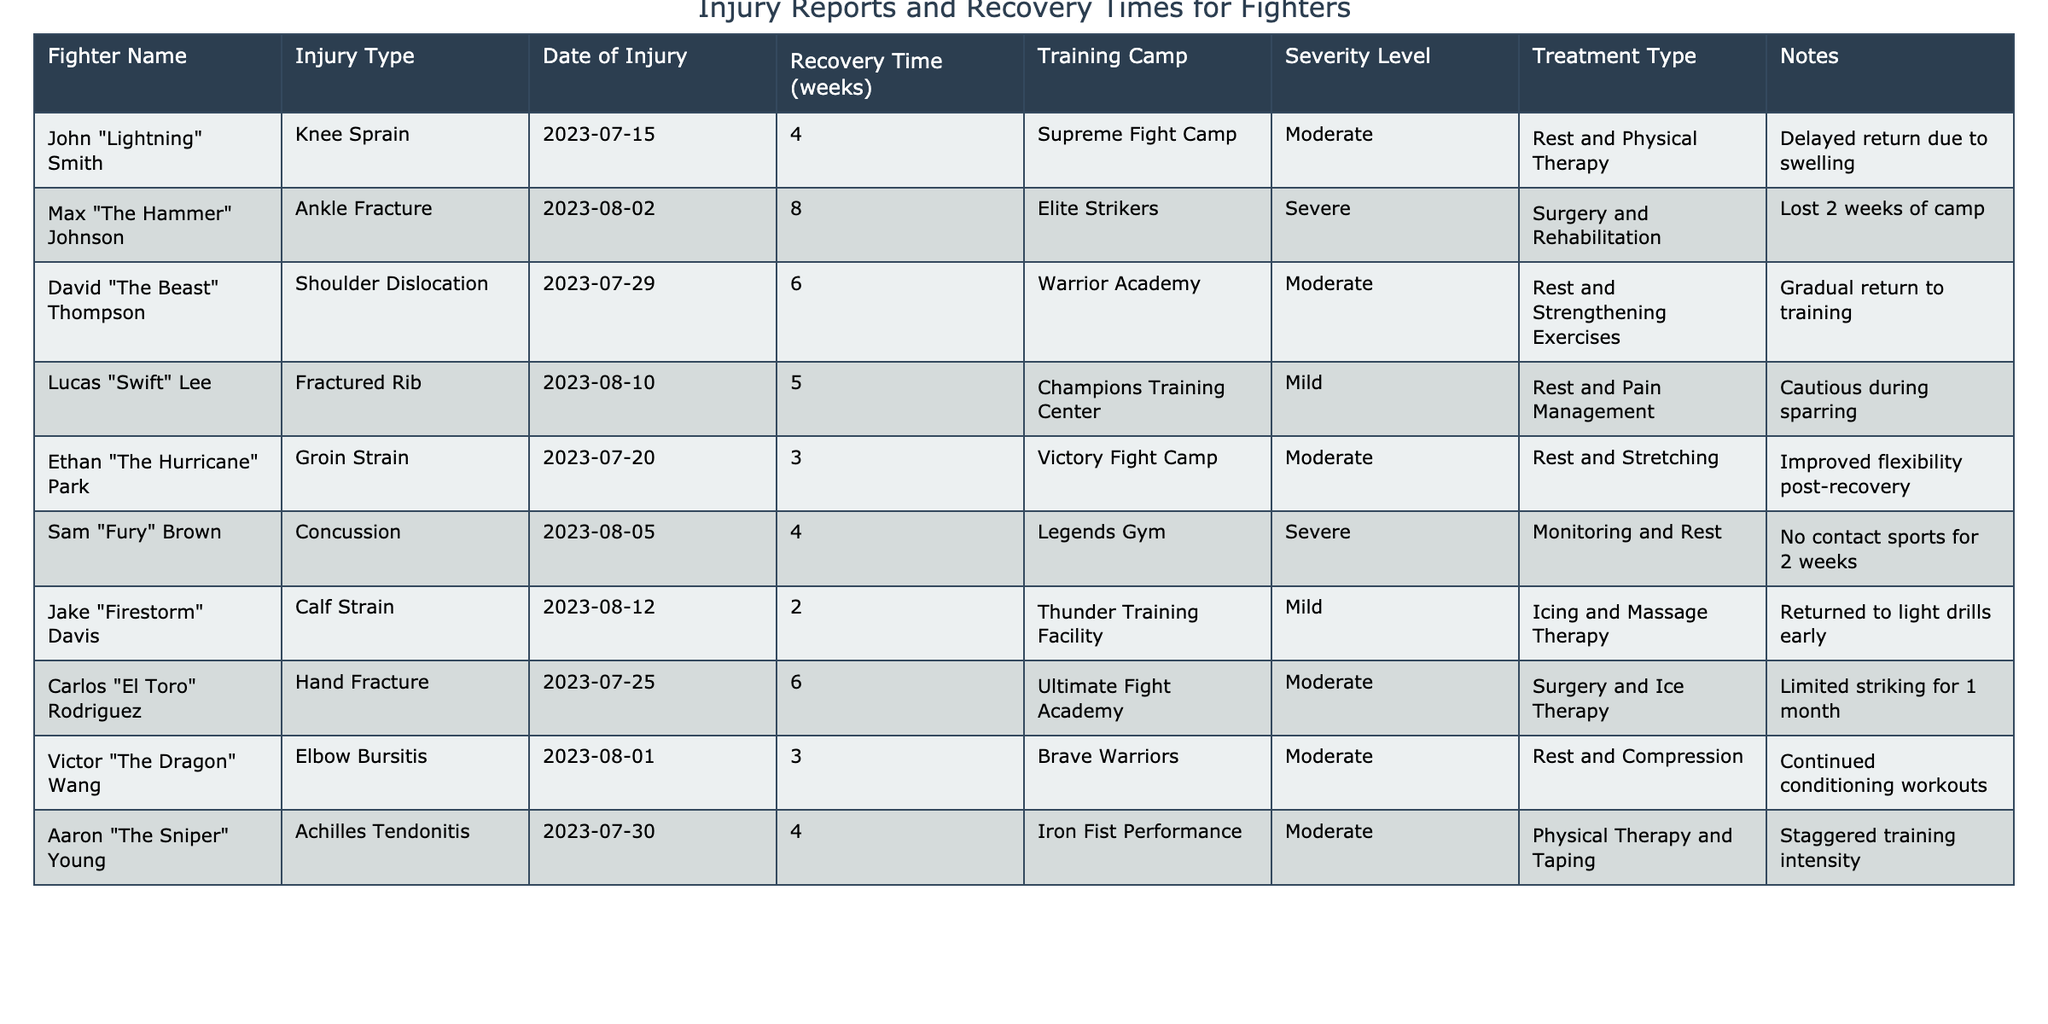What is the injury type for Max "The Hammer" Johnson? From the table, I can find that the injury type listed for Max "The Hammer" Johnson is Ankle Fracture.
Answer: Ankle Fracture How long did John "Lightning" Smith take to recover from his injury? The recovery time for John "Lightning" Smith is stated in the table as 4 weeks.
Answer: 4 weeks Which fighter had a recovery time of 3 weeks? By checking the table, I see that Ethan "The Hurricane" Park has a recovery time of 3 weeks due to a Groin Strain.
Answer: Ethan "The Hurricane" Park What is the average recovery time for the fighters listed? The recovery times are 4, 8, 6, 5, 3, 4, 2, 6, 3, and 4 weeks respectively. Adding these gives a total of 45 weeks, and with 10 fighters, the average is 45/10 = 4.5 weeks.
Answer: 4.5 weeks Is there any fighter with a severe injury severity level? Yes, there are two fighters listed with a severity level of Severe: Max "The Hammer" Johnson and Sam "Fury" Brown.
Answer: Yes Which fighter had the longest recovery time and what was it? Looking through the table, Max "The Hammer" Johnson had the longest recovery time of 8 weeks due to an Ankle Fracture.
Answer: Max "The Hammer" Johnson, 8 weeks What proportion of fighters had mild injuries? There are 3 fighters with mild injuries from a total of 10 fighters. Therefore, the proportion is 3/10 or 30%.
Answer: 30% Which fighter returned to training gradually after their injury? The table indicates that David "The Beast" Thompson returned to training gradually after suffering a Shoulder Dislocation.
Answer: David "The Beast" Thompson How many weeks did Carlos "El Toro" Rodriguez need to recover from his injury? The table states that Carlos "El Toro" Rodriguez had a recovery time of 6 weeks for a Hand Fracture.
Answer: 6 weeks What is the difference in recovery time between the fighter with the shortest recovery and the one with the longest? The shortest recovery time is 2 weeks (Jake "Firestorm" Davis), and the longest recovery time is 8 weeks (Max "The Hammer" Johnson). The difference is 8 - 2 = 6 weeks.
Answer: 6 weeks 